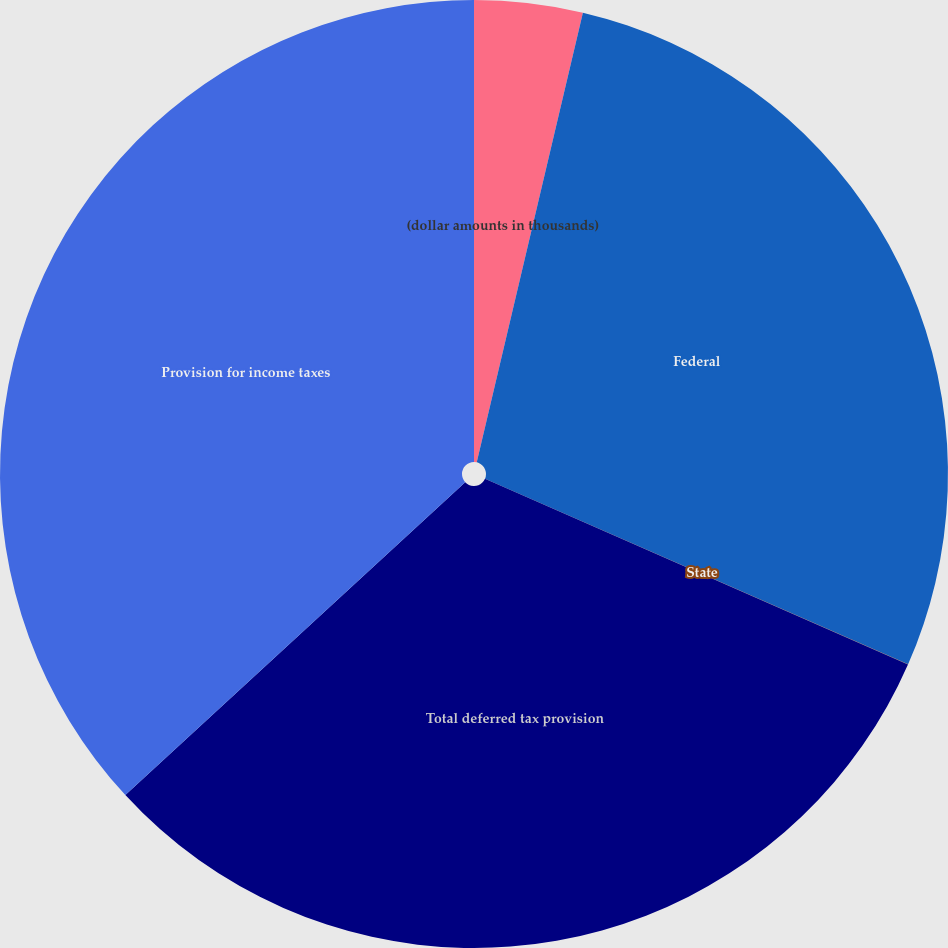Convert chart to OTSL. <chart><loc_0><loc_0><loc_500><loc_500><pie_chart><fcel>(dollar amounts in thousands)<fcel>Federal<fcel>State<fcel>Total deferred tax provision<fcel>Provision for income taxes<nl><fcel>3.69%<fcel>27.89%<fcel>0.01%<fcel>31.57%<fcel>36.85%<nl></chart> 